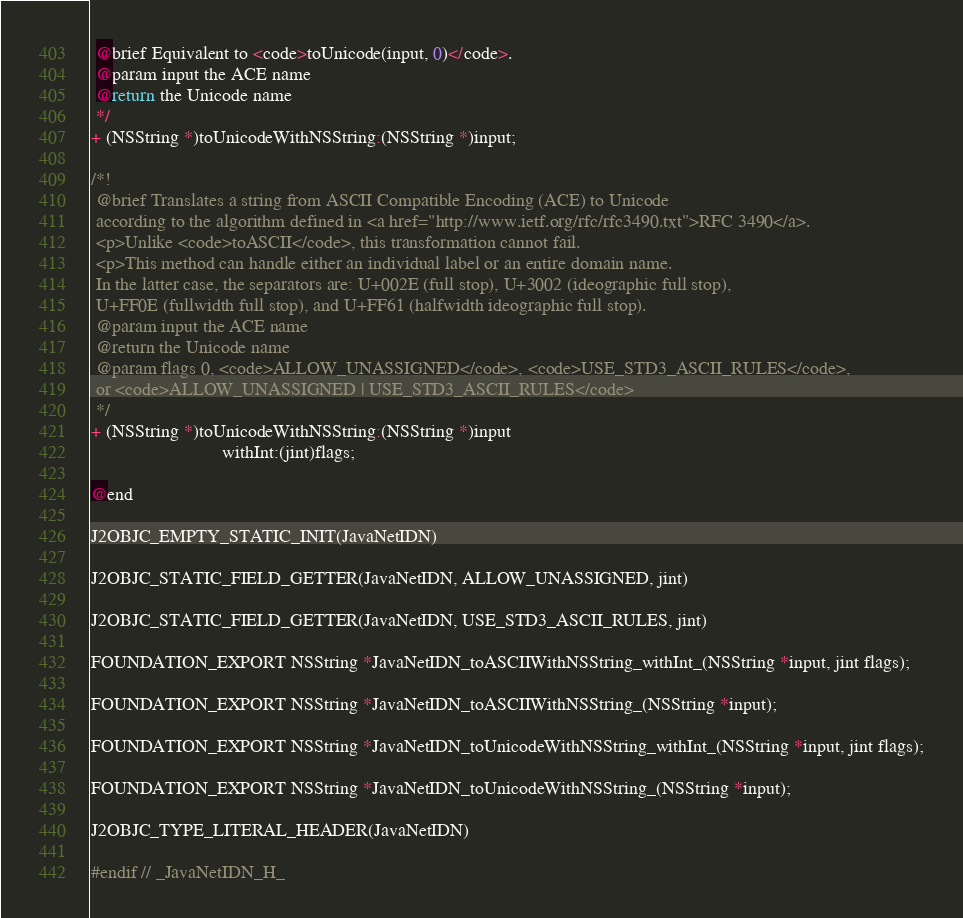<code> <loc_0><loc_0><loc_500><loc_500><_C_> @brief Equivalent to <code>toUnicode(input, 0)</code>.
 @param input the ACE name
 @return the Unicode name
 */
+ (NSString *)toUnicodeWithNSString:(NSString *)input;

/*!
 @brief Translates a string from ASCII Compatible Encoding (ACE) to Unicode
 according to the algorithm defined in <a href="http://www.ietf.org/rfc/rfc3490.txt">RFC 3490</a>.
 <p>Unlike <code>toASCII</code>, this transformation cannot fail.
 <p>This method can handle either an individual label or an entire domain name.
 In the latter case, the separators are: U+002E (full stop), U+3002 (ideographic full stop),
 U+FF0E (fullwidth full stop), and U+FF61 (halfwidth ideographic full stop).
 @param input the ACE name
 @return the Unicode name
 @param flags 0, <code>ALLOW_UNASSIGNED</code>, <code>USE_STD3_ASCII_RULES</code>,
 or <code>ALLOW_UNASSIGNED | USE_STD3_ASCII_RULES</code>
 */
+ (NSString *)toUnicodeWithNSString:(NSString *)input
                            withInt:(jint)flags;

@end

J2OBJC_EMPTY_STATIC_INIT(JavaNetIDN)

J2OBJC_STATIC_FIELD_GETTER(JavaNetIDN, ALLOW_UNASSIGNED, jint)

J2OBJC_STATIC_FIELD_GETTER(JavaNetIDN, USE_STD3_ASCII_RULES, jint)

FOUNDATION_EXPORT NSString *JavaNetIDN_toASCIIWithNSString_withInt_(NSString *input, jint flags);

FOUNDATION_EXPORT NSString *JavaNetIDN_toASCIIWithNSString_(NSString *input);

FOUNDATION_EXPORT NSString *JavaNetIDN_toUnicodeWithNSString_withInt_(NSString *input, jint flags);

FOUNDATION_EXPORT NSString *JavaNetIDN_toUnicodeWithNSString_(NSString *input);

J2OBJC_TYPE_LITERAL_HEADER(JavaNetIDN)

#endif // _JavaNetIDN_H_
</code> 